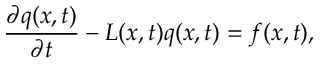Convert formula to latex. <formula><loc_0><loc_0><loc_500><loc_500>\frac { \partial q ( x , t ) } { \partial t } - L ( x , t ) q ( x , t ) = f ( x , t ) ,</formula> 